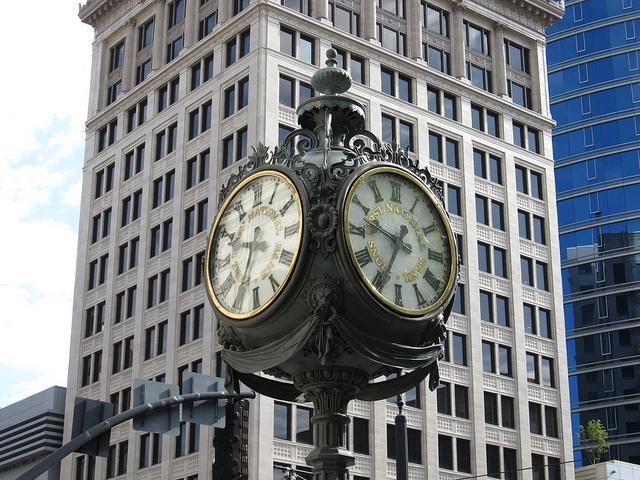What types of buildings are these?
Choose the right answer from the provided options to respond to the question.
Options: Mobile, high rise, historical, religious. High rise. 